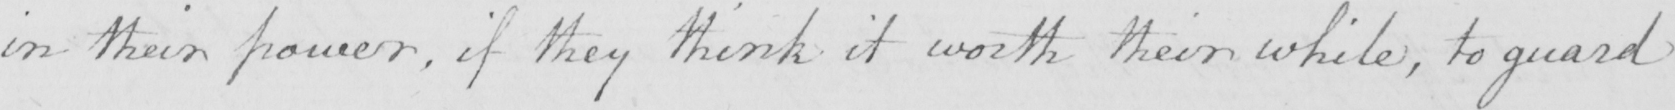What is written in this line of handwriting? in their power , if they think it worth their while , to guard 